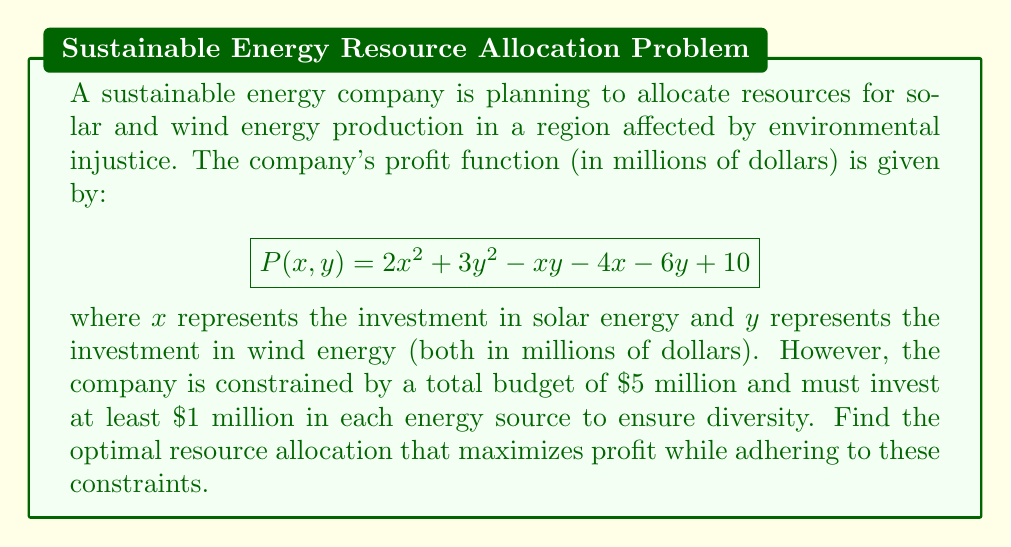Teach me how to tackle this problem. To solve this optimization problem with constraints, we'll use the method of Lagrange multipliers.

Step 1: Identify the constraints
- Budget constraint: $x + y = 5$
- Minimum investment constraints: $x ≥ 1$ and $y ≥ 1$

Step 2: Form the Lagrangian function
$$L(x,y,λ) = 2x^2 + 3y^2 - xy - 4x - 6y + 10 + λ(5 - x - y)$$

Step 3: Calculate partial derivatives and set them equal to zero
$$\frac{∂L}{∂x} = 4x - y - 4 - λ = 0$$
$$\frac{∂L}{∂y} = 6y - x - 6 - λ = 0$$
$$\frac{∂L}{∂λ} = 5 - x - y = 0$$

Step 4: Solve the system of equations
From the third equation: $y = 5 - x$
Substituting this into the first two equations:
$$4x - (5-x) - 4 - λ = 0$$
$$6(5-x) - x - 6 - λ = 0$$

Simplifying:
$$5x - 9 = λ$$
$$24 - 7x = λ$$

Equating these:
$$5x - 9 = 24 - 7x$$
$$12x = 33$$
$$x = \frac{11}{4} = 2.75$$

Therefore, $y = 5 - 2.75 = 2.25$

Step 5: Check constraints
Both $x$ and $y$ are greater than 1, satisfying the minimum investment constraints.

Step 6: Verify that this is a maximum
The Hessian matrix of $P$ is:
$$H = \begin{bmatrix} 4 & -1 \\ -1 & 6 \end{bmatrix}$$
Since the determinant is positive (23) and the upper-left entry is positive (4), this critical point is indeed a maximum.

Therefore, the optimal allocation is $2.75 million for solar energy and $2.25 million for wind energy.
Answer: Solar: $2.75 million, Wind: $2.25 million 